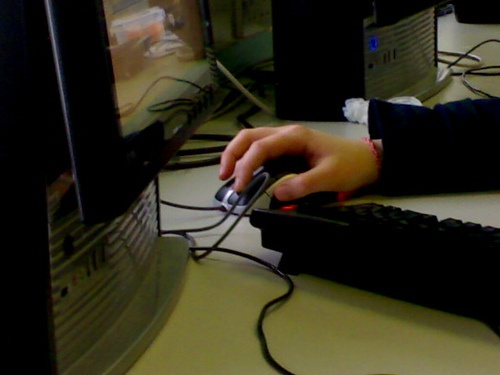Describe the objects in this image and their specific colors. I can see tv in black, olive, and gray tones, keyboard in black, gray, darkgreen, and maroon tones, people in black, maroon, brown, and gray tones, and mouse in black, darkgreen, gray, and maroon tones in this image. 